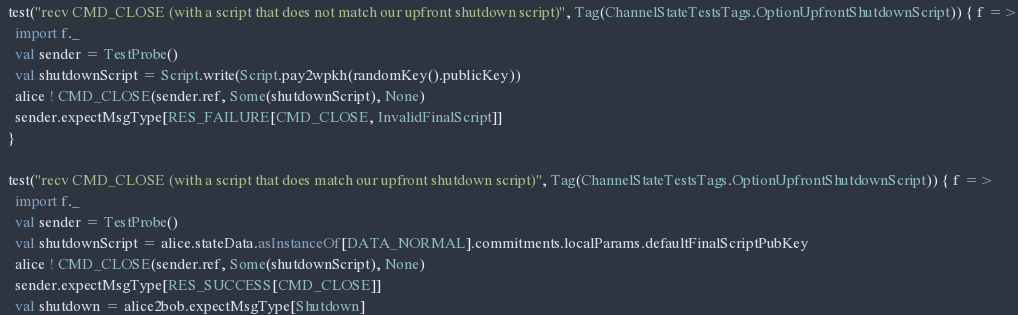Convert code to text. <code><loc_0><loc_0><loc_500><loc_500><_Scala_>  test("recv CMD_CLOSE (with a script that does not match our upfront shutdown script)", Tag(ChannelStateTestsTags.OptionUpfrontShutdownScript)) { f =>
    import f._
    val sender = TestProbe()
    val shutdownScript = Script.write(Script.pay2wpkh(randomKey().publicKey))
    alice ! CMD_CLOSE(sender.ref, Some(shutdownScript), None)
    sender.expectMsgType[RES_FAILURE[CMD_CLOSE, InvalidFinalScript]]
  }

  test("recv CMD_CLOSE (with a script that does match our upfront shutdown script)", Tag(ChannelStateTestsTags.OptionUpfrontShutdownScript)) { f =>
    import f._
    val sender = TestProbe()
    val shutdownScript = alice.stateData.asInstanceOf[DATA_NORMAL].commitments.localParams.defaultFinalScriptPubKey
    alice ! CMD_CLOSE(sender.ref, Some(shutdownScript), None)
    sender.expectMsgType[RES_SUCCESS[CMD_CLOSE]]
    val shutdown = alice2bob.expectMsgType[Shutdown]</code> 